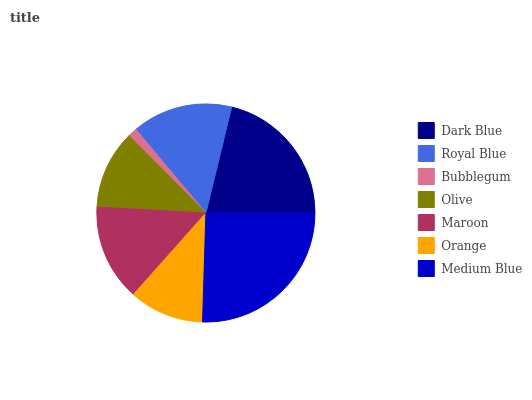Is Bubblegum the minimum?
Answer yes or no. Yes. Is Medium Blue the maximum?
Answer yes or no. Yes. Is Royal Blue the minimum?
Answer yes or no. No. Is Royal Blue the maximum?
Answer yes or no. No. Is Dark Blue greater than Royal Blue?
Answer yes or no. Yes. Is Royal Blue less than Dark Blue?
Answer yes or no. Yes. Is Royal Blue greater than Dark Blue?
Answer yes or no. No. Is Dark Blue less than Royal Blue?
Answer yes or no. No. Is Maroon the high median?
Answer yes or no. Yes. Is Maroon the low median?
Answer yes or no. Yes. Is Dark Blue the high median?
Answer yes or no. No. Is Olive the low median?
Answer yes or no. No. 